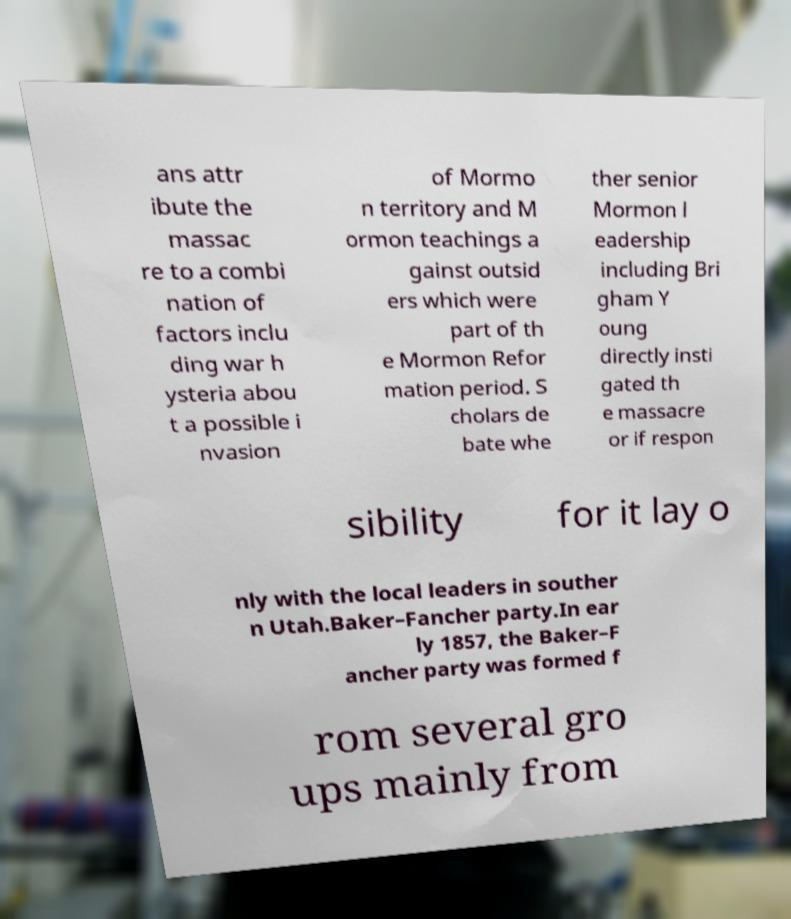Can you accurately transcribe the text from the provided image for me? ans attr ibute the massac re to a combi nation of factors inclu ding war h ysteria abou t a possible i nvasion of Mormo n territory and M ormon teachings a gainst outsid ers which were part of th e Mormon Refor mation period. S cholars de bate whe ther senior Mormon l eadership including Bri gham Y oung directly insti gated th e massacre or if respon sibility for it lay o nly with the local leaders in souther n Utah.Baker–Fancher party.In ear ly 1857, the Baker–F ancher party was formed f rom several gro ups mainly from 